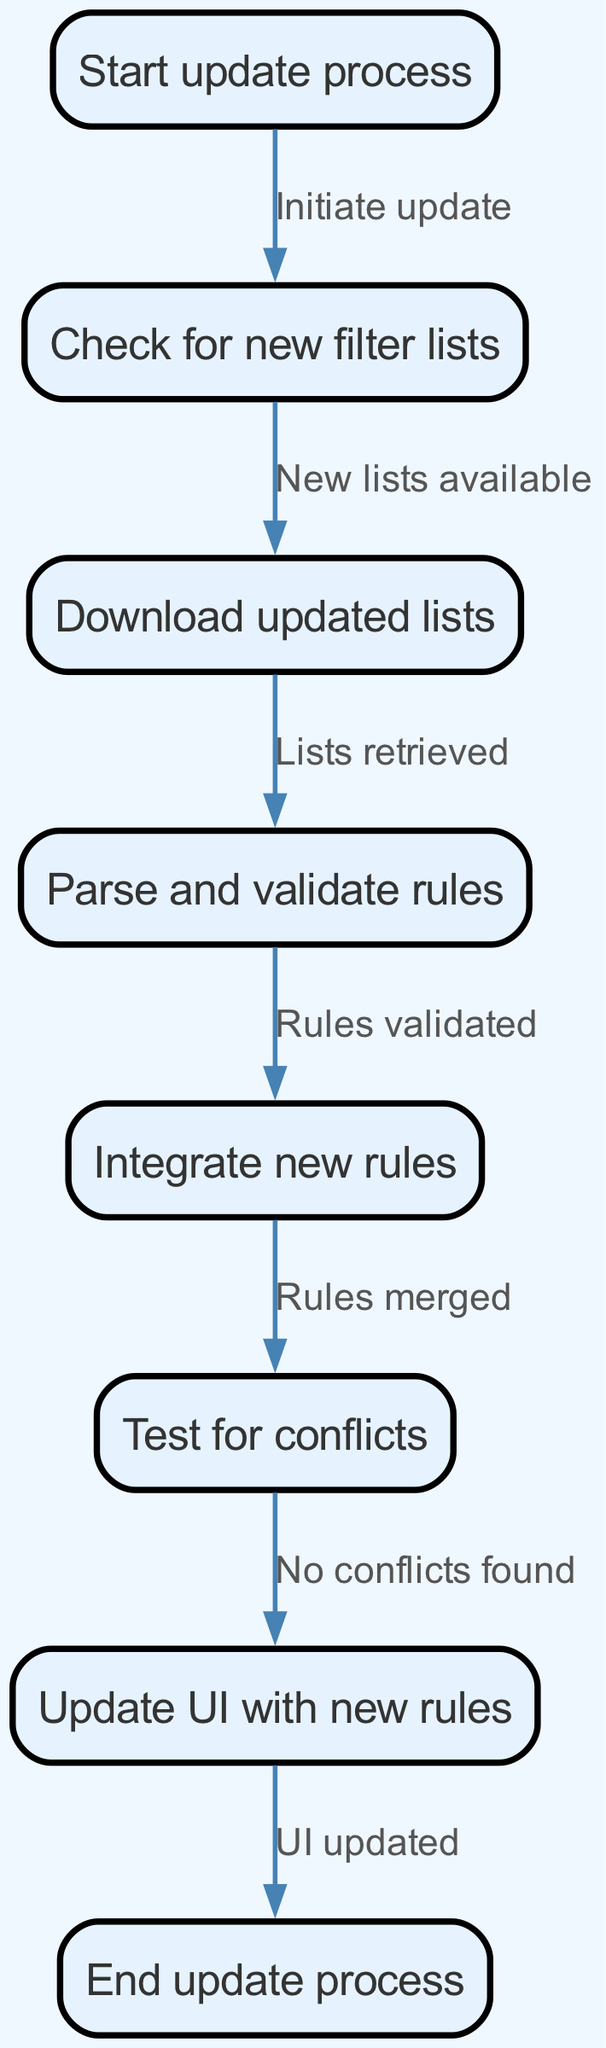What is the first step in the update process? The first step is labeled as "Start update process," which is the entry point of the workflow.
Answer: Start update process How many nodes are there in the diagram? By counting the individual nodes listed in the 'nodes' section of the data, we find there are a total of eight nodes.
Answer: 8 What happens after checking for new filter lists? After checking for new filter lists, the next step transitions to "Download updated lists," indicating the action taken when new lists are found.
Answer: Download updated lists Which step follows after integrating new rules? Following the integration of new rules, the next step is to "Test for conflicts," meaning that the process moves on to checking for any issues after merging rules.
Answer: Test for conflicts What is the final action taken in this workflow? The final action in the workflow is "End update process," which signifies the completion of the entire update procedure.
Answer: End update process What relationship exists between downloading updated lists and parsing rules? The relationship is that after "Lists retrieved" (downloading), the next action is to "Parse and validate rules." This indicates that parsing occurs only after successful downloading.
Answer: Parse and validate rules How many edges are there connecting the nodes? By examining the 'edges' section of the data, we see there are seven connections (edges) among the eight nodes.
Answer: 7 What condition must be met to proceed from testing to updating the UI? The condition to proceed is "No conflicts found," meaning that the testing phase must confirm no issues before updating the User Interface with new rules.
Answer: No conflicts found 